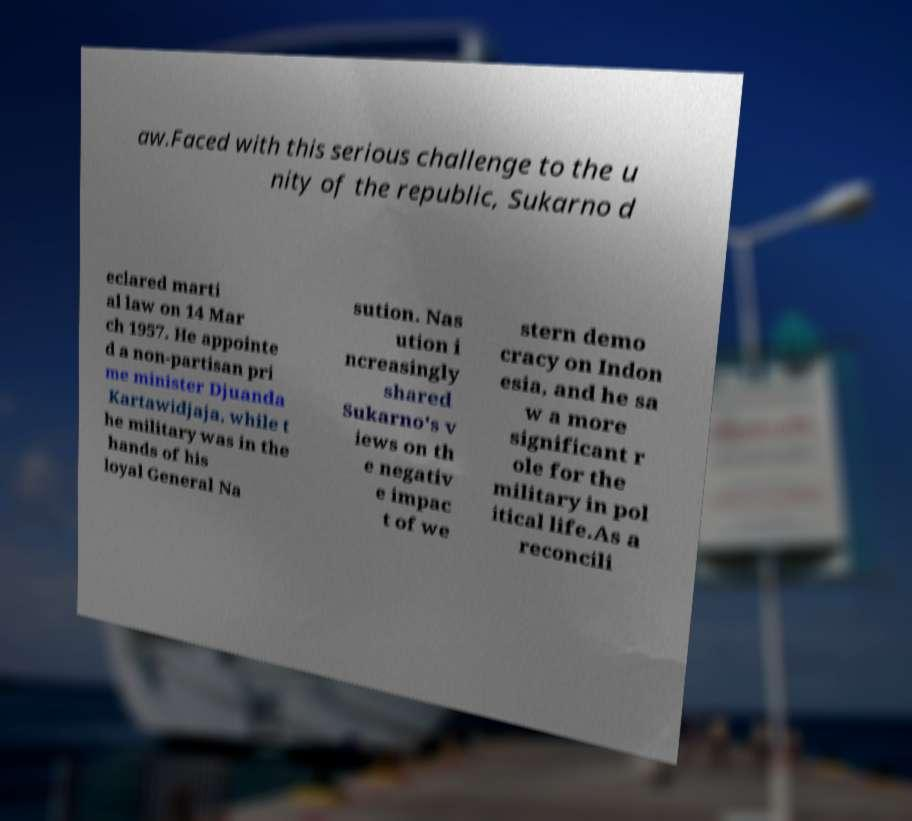I need the written content from this picture converted into text. Can you do that? aw.Faced with this serious challenge to the u nity of the republic, Sukarno d eclared marti al law on 14 Mar ch 1957. He appointe d a non-partisan pri me minister Djuanda Kartawidjaja, while t he military was in the hands of his loyal General Na sution. Nas ution i ncreasingly shared Sukarno's v iews on th e negativ e impac t of we stern demo cracy on Indon esia, and he sa w a more significant r ole for the military in pol itical life.As a reconcili 